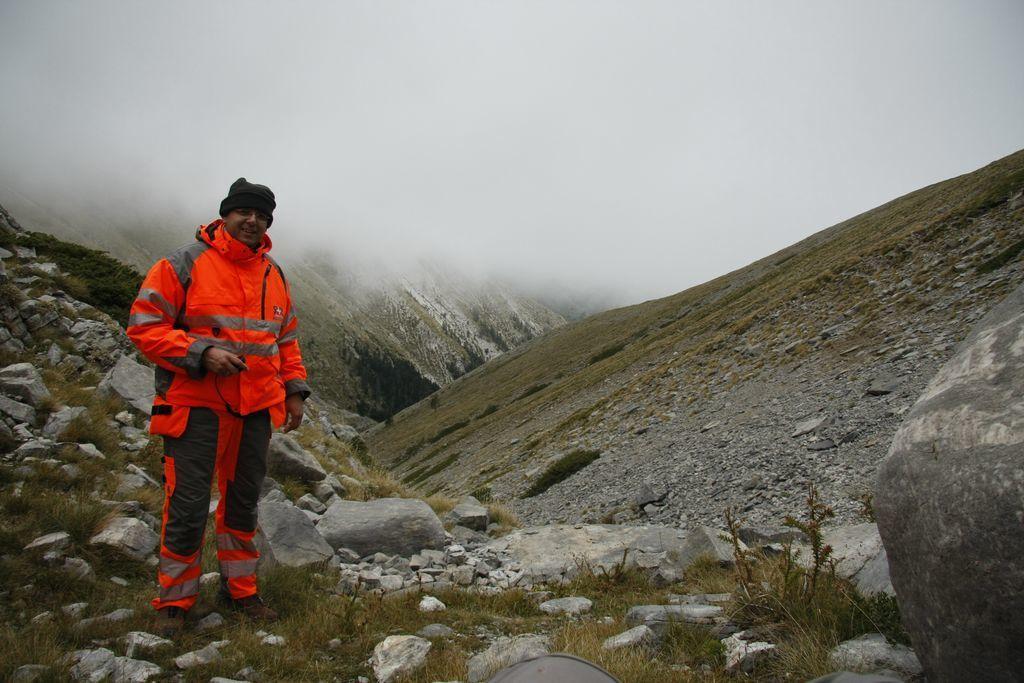Could you give a brief overview of what you see in this image? In this image there is a person. At the bottom of the image there are rocks and there's grass on the surface. In the background of the image there are mountains. At the top of the image there is sky. 